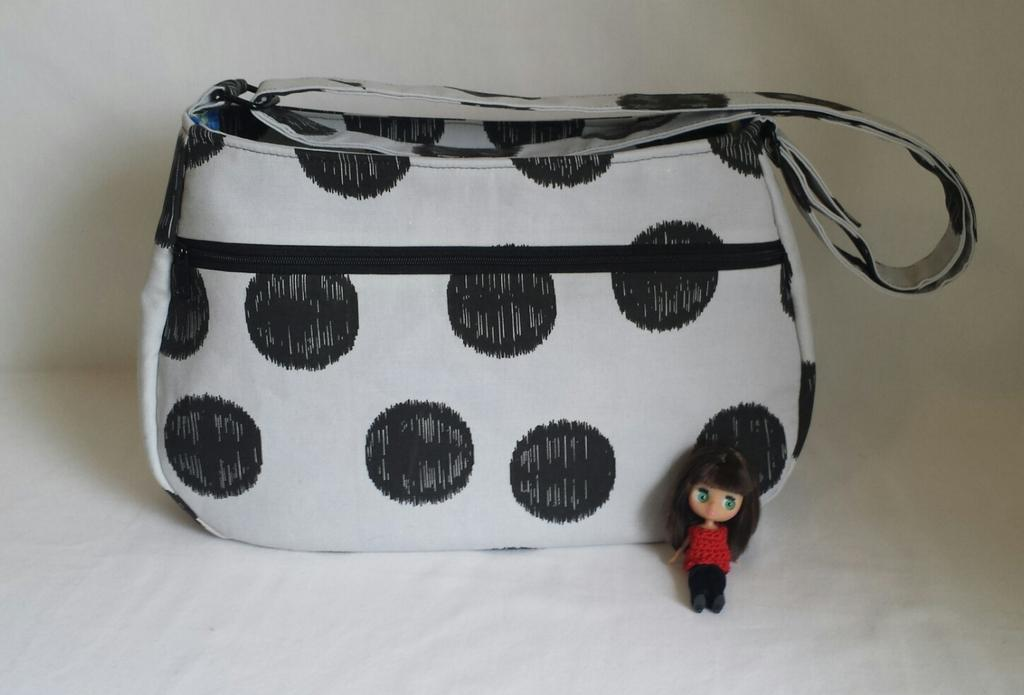What type of furniture is in the image? There is a couch in the image. What object is placed on the couch? There is a handbag on the couch. What is the color scheme of the handbag? The handbag is in black and white color. What type of oil is being used to draw the line on the lumber in the image? There is no oil, line, or lumber present in the image. 